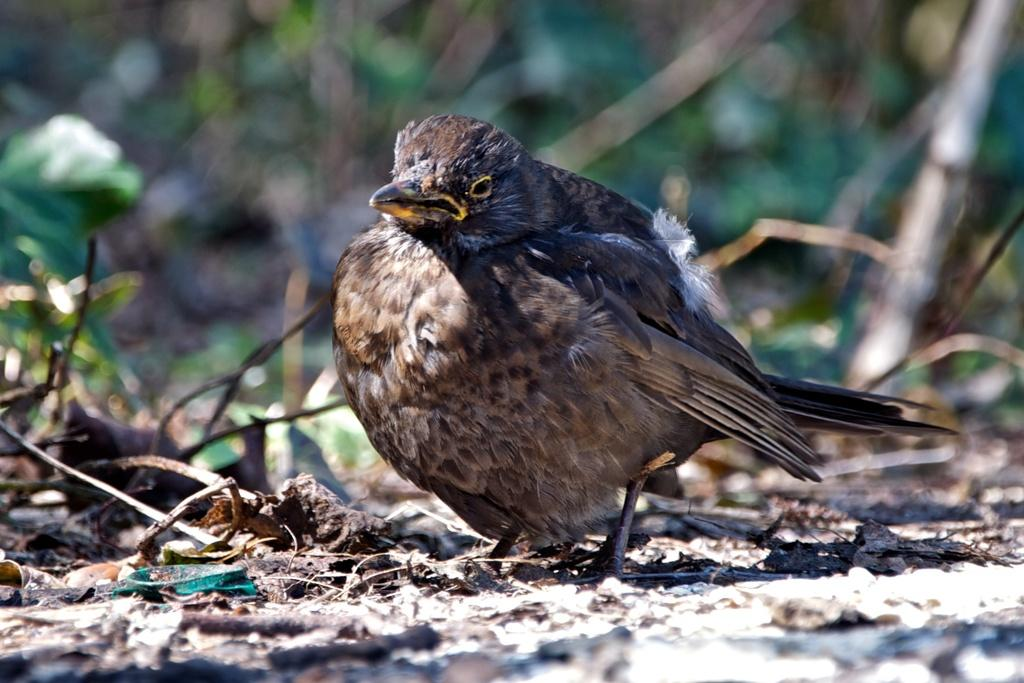What type of animal is in the image? There is a bird in the image. What is the bird doing in the image? The bird is standing. Can you describe the bird's color? The bird appears to be light brownish in color. How would you describe the background of the image? The background of the image is blurry. What type of planes does the bird need in the image? There are no planes present in the image, and the bird does not require any planes. Is there a doll accompanying the bird in the image? There is no doll present in the image; it only features a bird. 